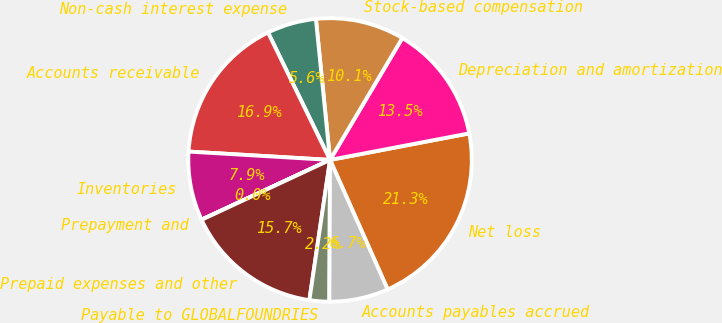Convert chart. <chart><loc_0><loc_0><loc_500><loc_500><pie_chart><fcel>Net loss<fcel>Depreciation and amortization<fcel>Stock-based compensation<fcel>Non-cash interest expense<fcel>Accounts receivable<fcel>Inventories<fcel>Prepayment and<fcel>Prepaid expenses and other<fcel>Payable to GLOBALFOUNDRIES<fcel>Accounts payables accrued<nl><fcel>21.34%<fcel>13.48%<fcel>10.11%<fcel>5.62%<fcel>16.85%<fcel>7.87%<fcel>0.01%<fcel>15.73%<fcel>2.25%<fcel>6.74%<nl></chart> 